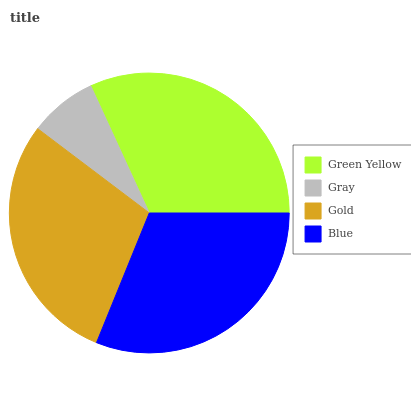Is Gray the minimum?
Answer yes or no. Yes. Is Green Yellow the maximum?
Answer yes or no. Yes. Is Gold the minimum?
Answer yes or no. No. Is Gold the maximum?
Answer yes or no. No. Is Gold greater than Gray?
Answer yes or no. Yes. Is Gray less than Gold?
Answer yes or no. Yes. Is Gray greater than Gold?
Answer yes or no. No. Is Gold less than Gray?
Answer yes or no. No. Is Blue the high median?
Answer yes or no. Yes. Is Gold the low median?
Answer yes or no. Yes. Is Green Yellow the high median?
Answer yes or no. No. Is Gray the low median?
Answer yes or no. No. 